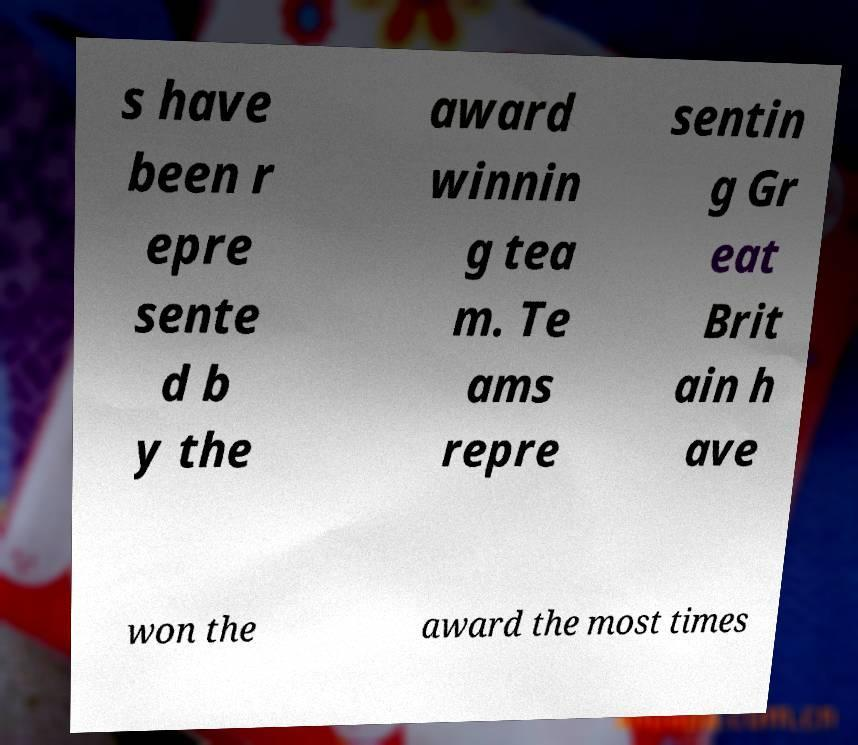There's text embedded in this image that I need extracted. Can you transcribe it verbatim? s have been r epre sente d b y the award winnin g tea m. Te ams repre sentin g Gr eat Brit ain h ave won the award the most times 